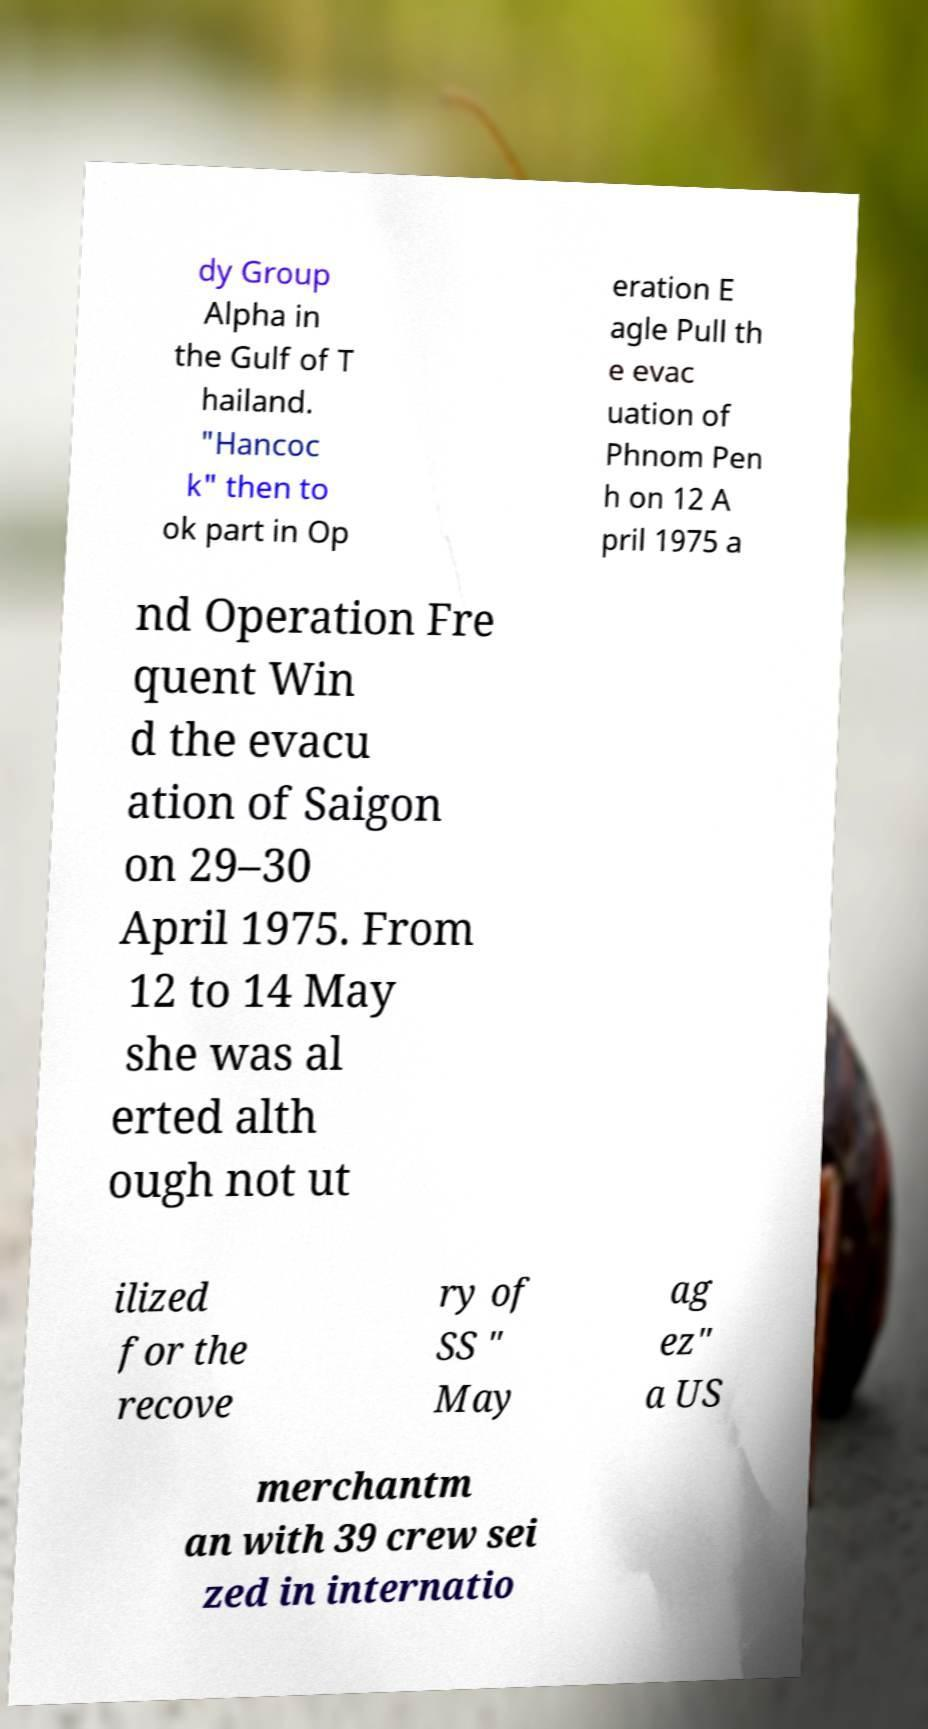Can you accurately transcribe the text from the provided image for me? dy Group Alpha in the Gulf of T hailand. "Hancoc k" then to ok part in Op eration E agle Pull th e evac uation of Phnom Pen h on 12 A pril 1975 a nd Operation Fre quent Win d the evacu ation of Saigon on 29–30 April 1975. From 12 to 14 May she was al erted alth ough not ut ilized for the recove ry of SS " May ag ez" a US merchantm an with 39 crew sei zed in internatio 